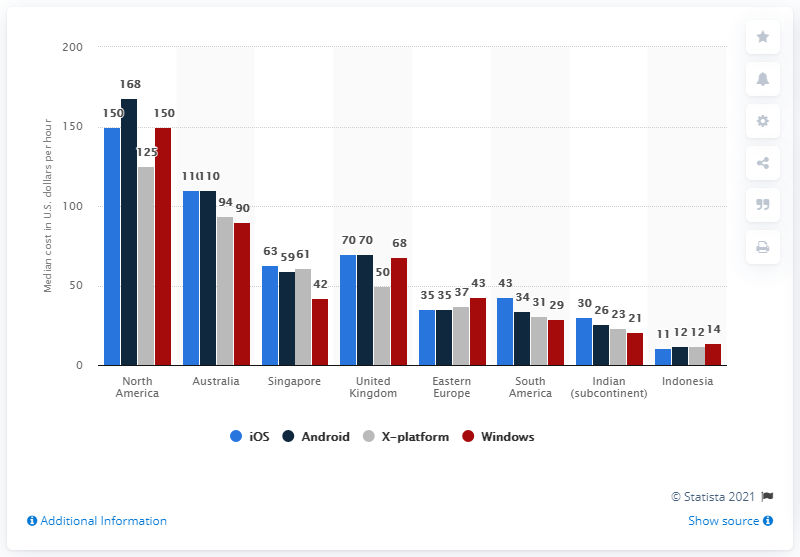Highlight a few significant elements in this photo. The average median cost of Android application development in North America and Australia is approximately $139 per hour. The median cost of Android application development in North America is approximately $168 per hour. 